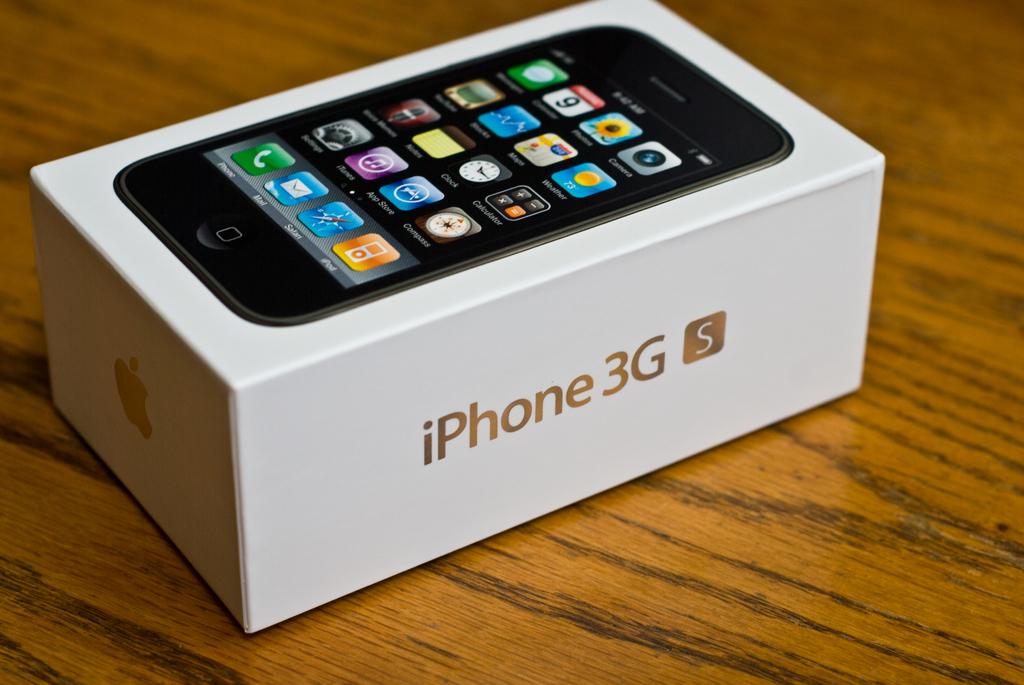What kind of iphone is it?
Provide a succinct answer. Iphone 3g s. 